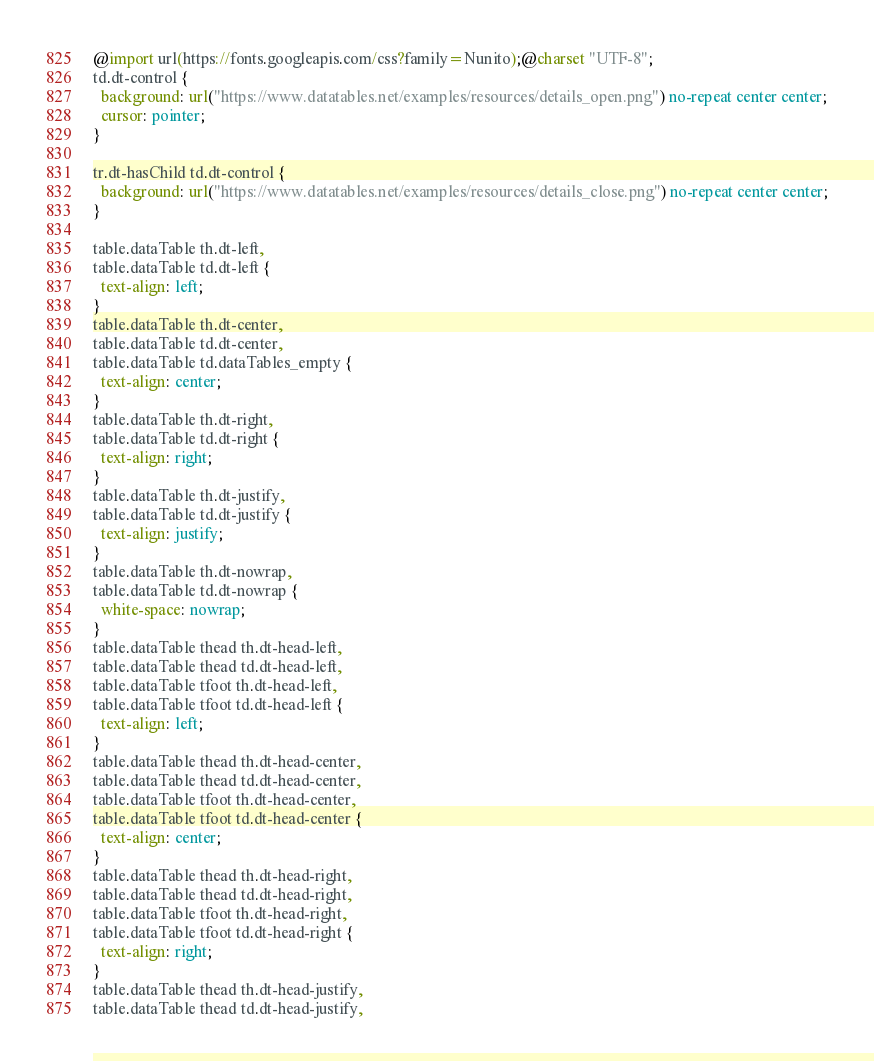Convert code to text. <code><loc_0><loc_0><loc_500><loc_500><_CSS_>@import url(https://fonts.googleapis.com/css?family=Nunito);@charset "UTF-8";
td.dt-control {
  background: url("https://www.datatables.net/examples/resources/details_open.png") no-repeat center center;
  cursor: pointer;
}

tr.dt-hasChild td.dt-control {
  background: url("https://www.datatables.net/examples/resources/details_close.png") no-repeat center center;
}

table.dataTable th.dt-left,
table.dataTable td.dt-left {
  text-align: left;
}
table.dataTable th.dt-center,
table.dataTable td.dt-center,
table.dataTable td.dataTables_empty {
  text-align: center;
}
table.dataTable th.dt-right,
table.dataTable td.dt-right {
  text-align: right;
}
table.dataTable th.dt-justify,
table.dataTable td.dt-justify {
  text-align: justify;
}
table.dataTable th.dt-nowrap,
table.dataTable td.dt-nowrap {
  white-space: nowrap;
}
table.dataTable thead th.dt-head-left,
table.dataTable thead td.dt-head-left,
table.dataTable tfoot th.dt-head-left,
table.dataTable tfoot td.dt-head-left {
  text-align: left;
}
table.dataTable thead th.dt-head-center,
table.dataTable thead td.dt-head-center,
table.dataTable tfoot th.dt-head-center,
table.dataTable tfoot td.dt-head-center {
  text-align: center;
}
table.dataTable thead th.dt-head-right,
table.dataTable thead td.dt-head-right,
table.dataTable tfoot th.dt-head-right,
table.dataTable tfoot td.dt-head-right {
  text-align: right;
}
table.dataTable thead th.dt-head-justify,
table.dataTable thead td.dt-head-justify,</code> 